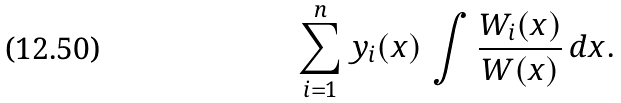<formula> <loc_0><loc_0><loc_500><loc_500>\sum _ { i = 1 } ^ { n } y _ { i } ( x ) \, \int { \frac { W _ { i } ( x ) } { W ( x ) } } \, d x .</formula> 